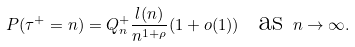<formula> <loc_0><loc_0><loc_500><loc_500>P ( \tau ^ { + } = n ) = Q _ { n } ^ { + } \frac { l ( n ) } { n ^ { 1 + \rho } } ( 1 + o ( 1 ) ) \text { \ as } n \rightarrow \infty .</formula> 